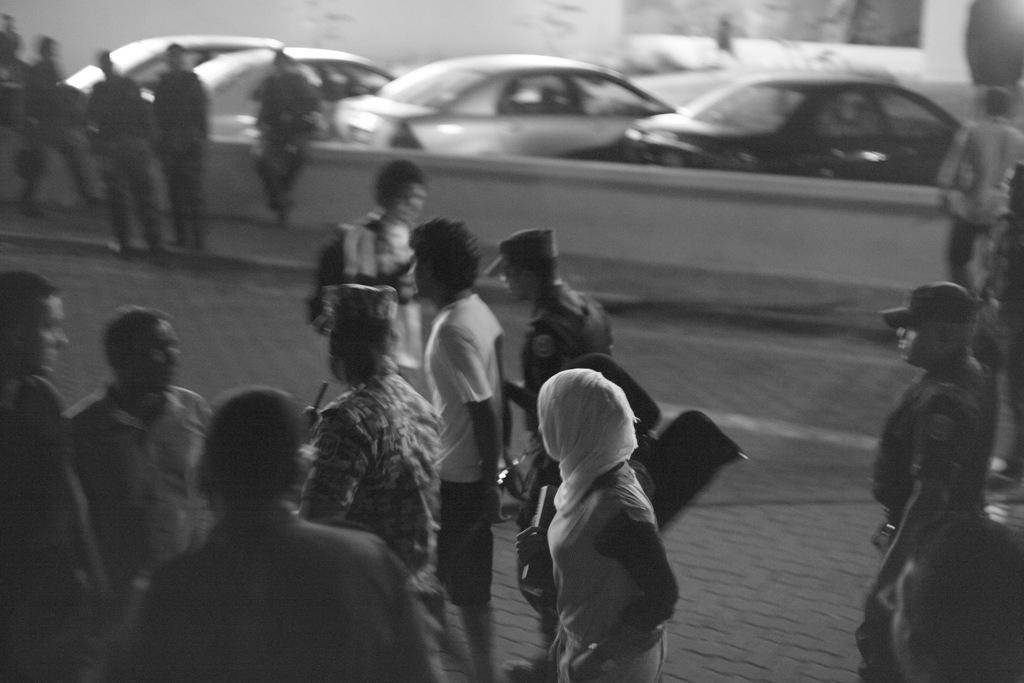In one or two sentences, can you explain what this image depicts? As we can see in the image there are few people here and there, cars and a wall. 